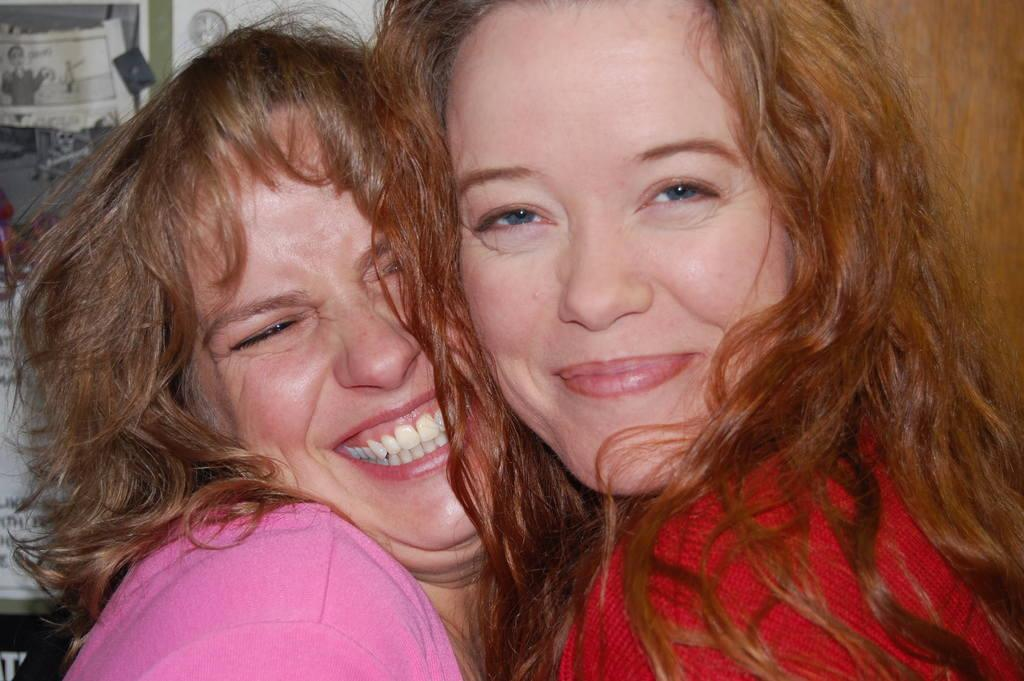How many people are in the image? There are two women in the image. What is the facial expression of the women? The women are smiling. What can be seen in the right in the background? There is a door on the right side in the background. What is hanging on the wall in the background? There are papers on the wall in the background. What type of rice is being cooked in the image? There is no rice present in the image. What is the distance between the two women in the image? The distance between the two women cannot be determined from the image alone, as there is no reference point for scale. 